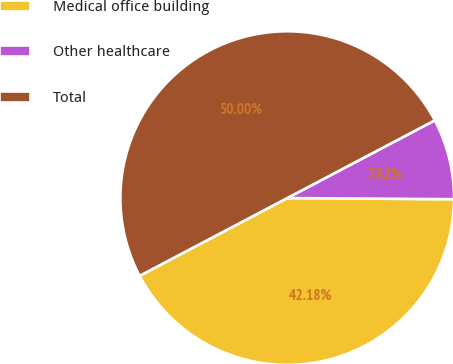Convert chart to OTSL. <chart><loc_0><loc_0><loc_500><loc_500><pie_chart><fcel>Medical office building<fcel>Other healthcare<fcel>Total<nl><fcel>42.18%<fcel>7.82%<fcel>50.0%<nl></chart> 